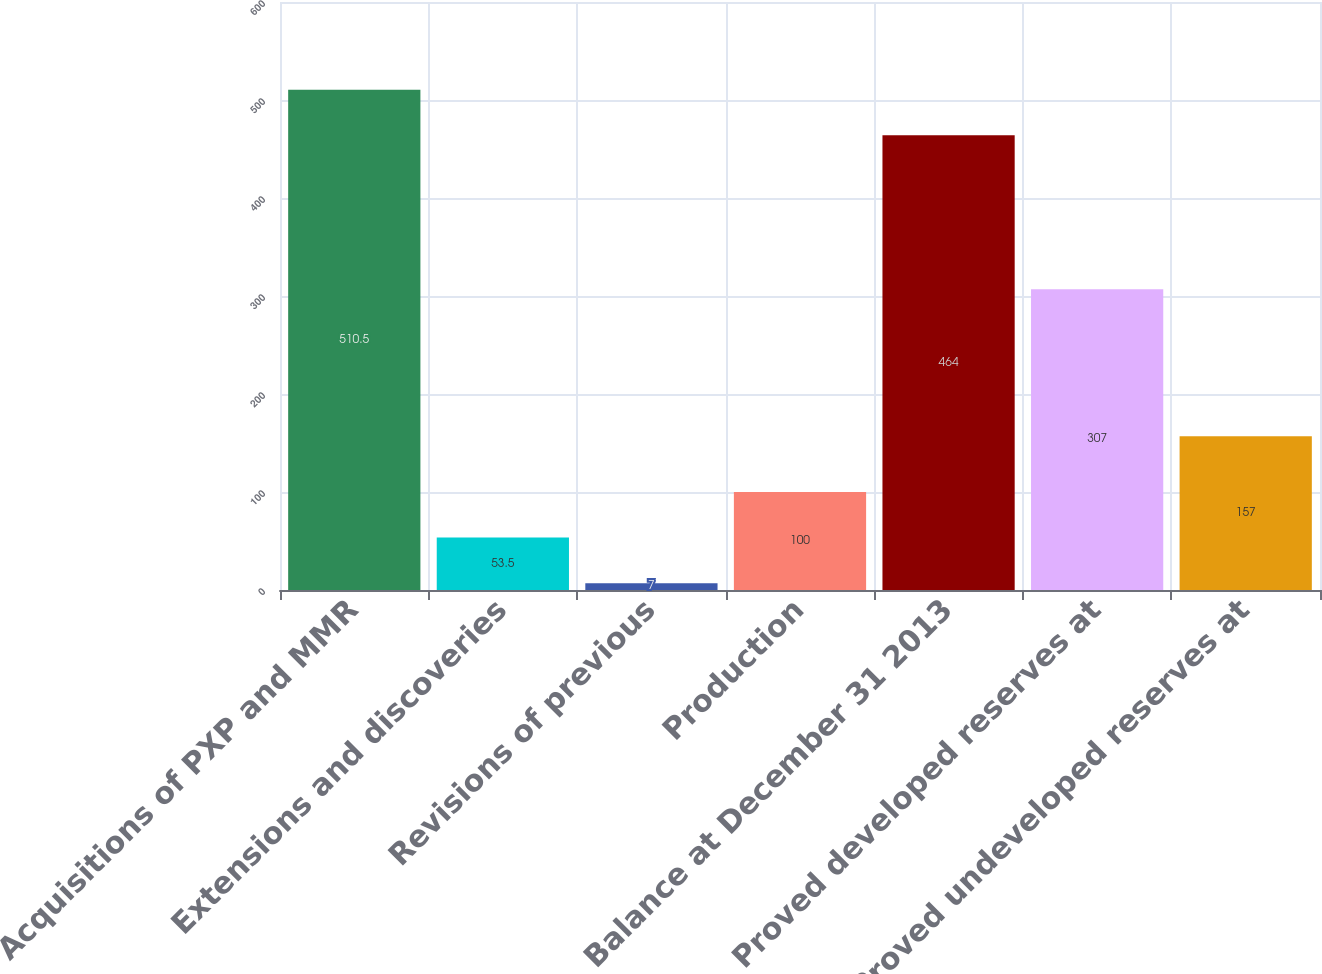Convert chart. <chart><loc_0><loc_0><loc_500><loc_500><bar_chart><fcel>Acquisitions of PXP and MMR<fcel>Extensions and discoveries<fcel>Revisions of previous<fcel>Production<fcel>Balance at December 31 2013<fcel>Proved developed reserves at<fcel>Proved undeveloped reserves at<nl><fcel>510.5<fcel>53.5<fcel>7<fcel>100<fcel>464<fcel>307<fcel>157<nl></chart> 